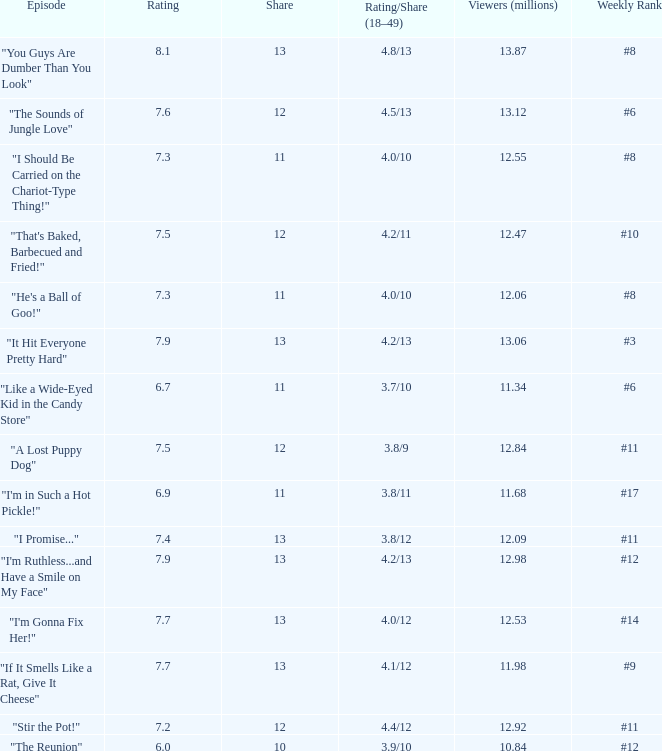What is the mean score for "a lost puppy dog"? 7.5. 